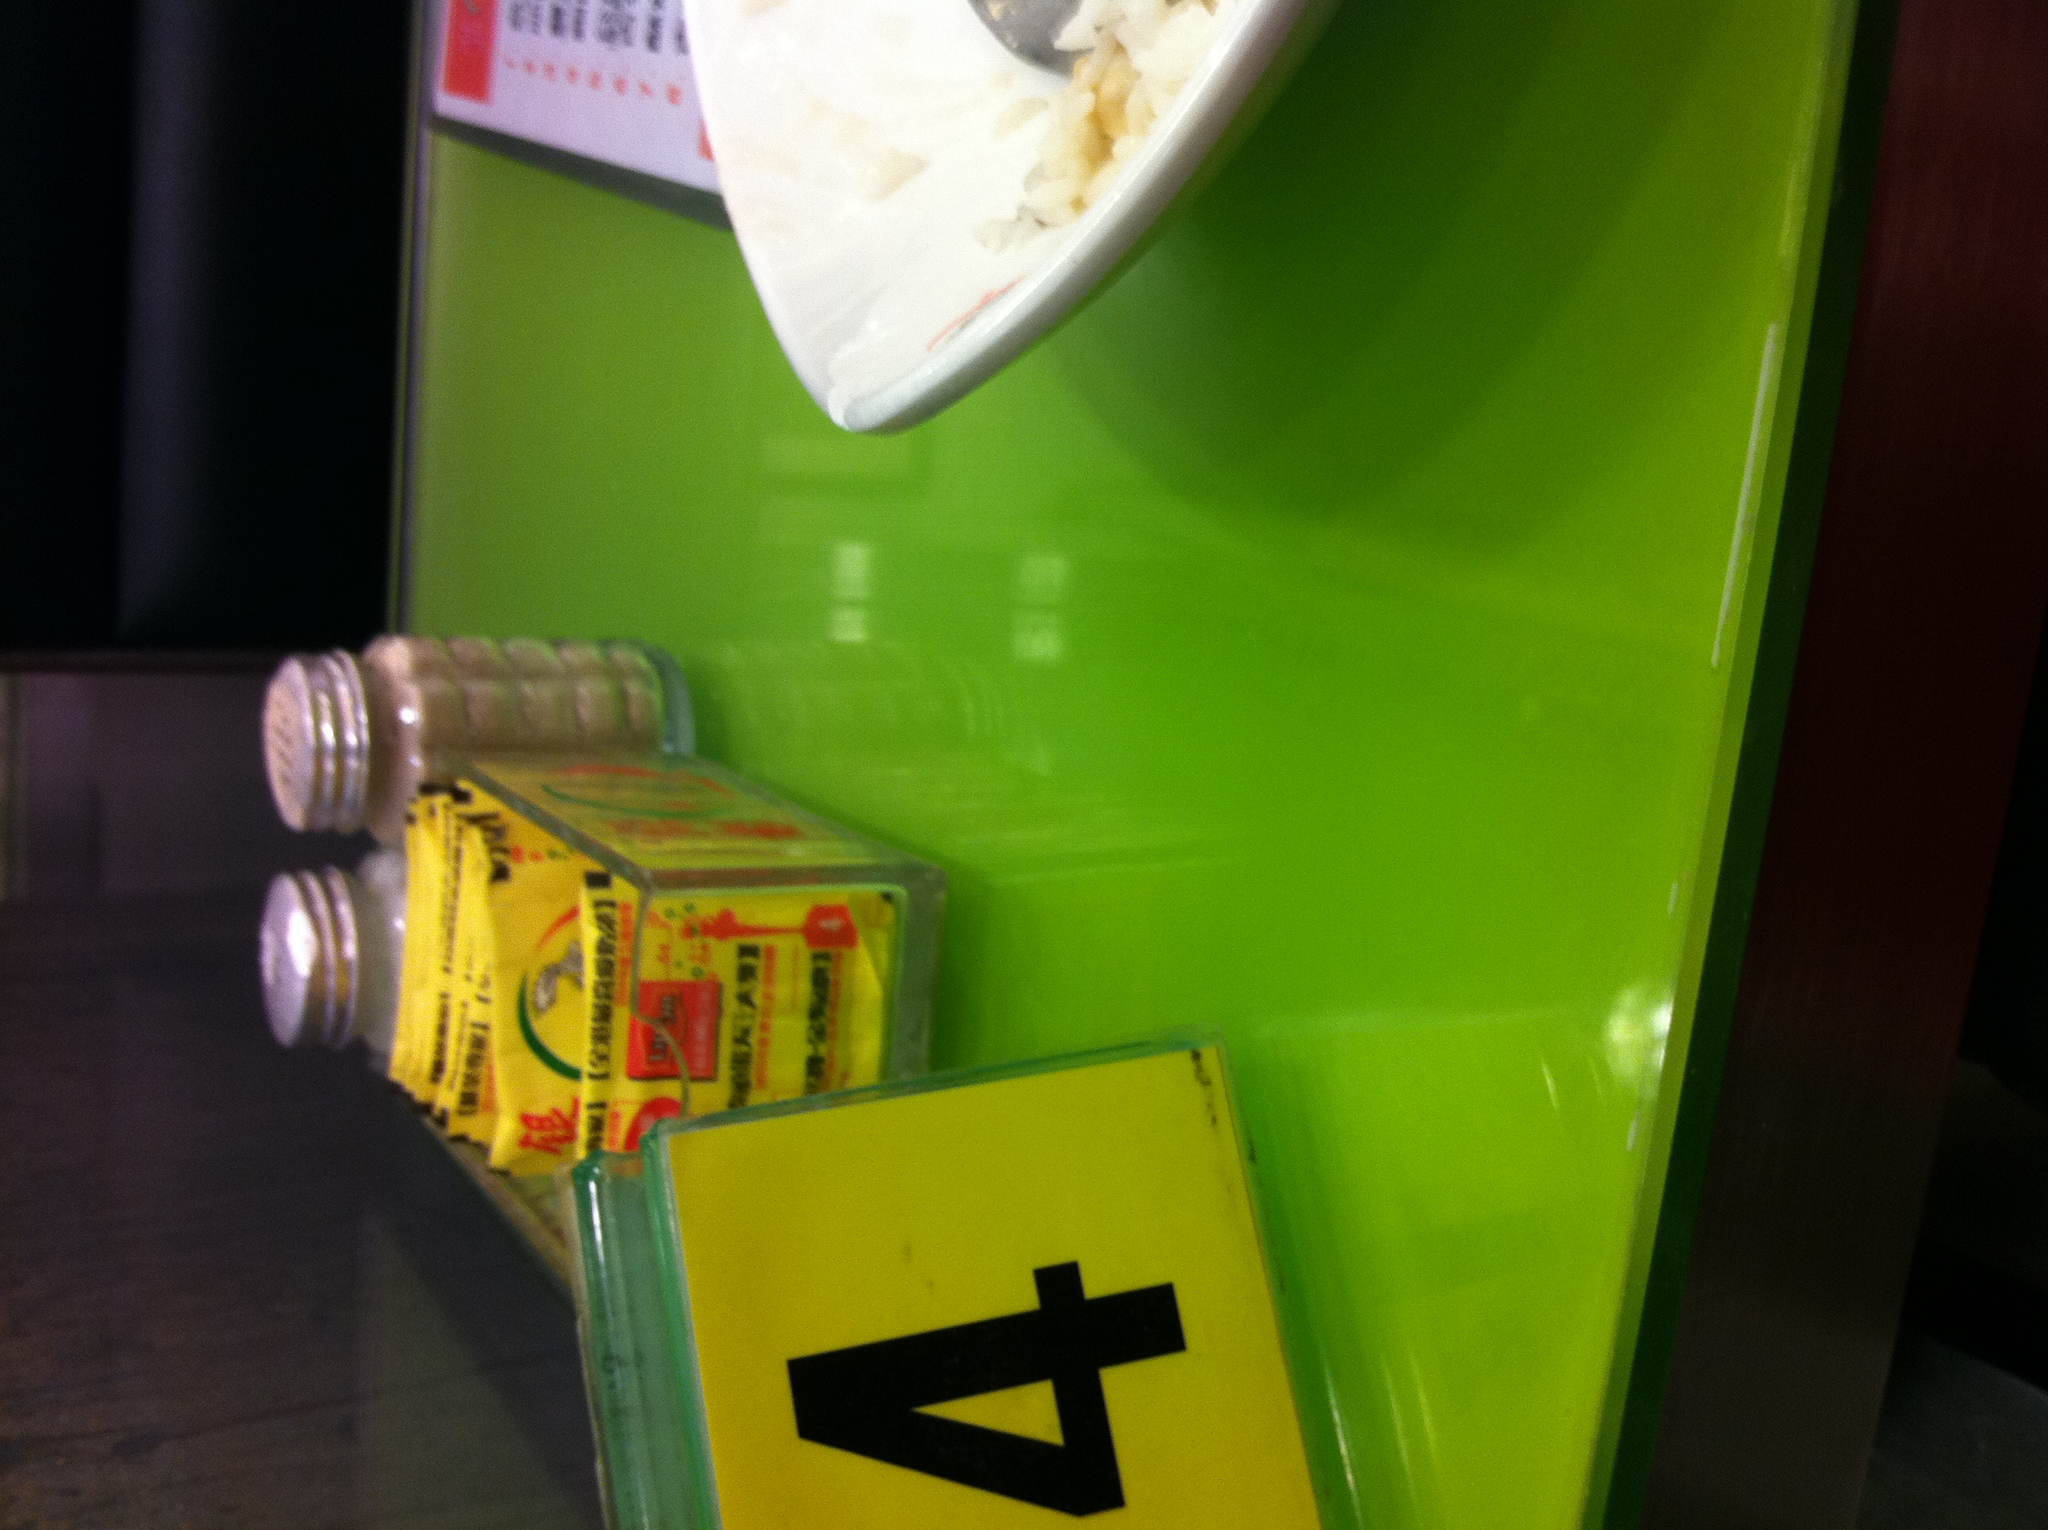Describe a long scenario that might happen at this table. At table number 4, a family of four sits down for dinner. The parents are busy settling their children—an enthusiastic five-year-old boy and a curious seven-year-old girl—in their seats. Tonight, they are celebrating the mother's promotion at work. As the father places the order, the children chat excitedly about their day at school, displaying their drawings and talking about their friends. The server, with a warm smile, brings the food, including a couple of the kids' favorites: spaghetti and chicken nuggets. There's a round of playful banter about who should use the salt shaker first. The parents share a comforting look as they discuss adult matters and plans for the future. The conversation flows, sometimes interrupted by the children's questions or a squabble over the last piece of chicken nugget. As they finish their meal, the server brings out a small celebratory cake with a single candle. They sing and clap for the mother, who blushes with happiness. The evening ends with a happy family picture taken by the server, capturing a moment of joy and togetherness. The table, now cleared, holds on to the memory of this family dinner as it awaits the next set of diners. 